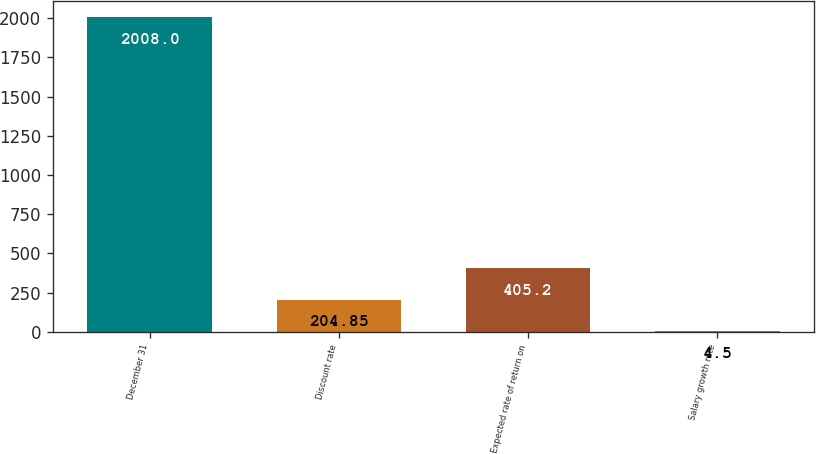Convert chart to OTSL. <chart><loc_0><loc_0><loc_500><loc_500><bar_chart><fcel>December 31<fcel>Discount rate<fcel>Expected rate of return on<fcel>Salary growth rate<nl><fcel>2008<fcel>204.85<fcel>405.2<fcel>4.5<nl></chart> 